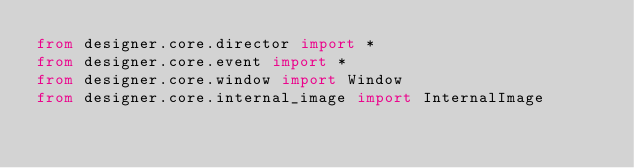Convert code to text. <code><loc_0><loc_0><loc_500><loc_500><_Python_>from designer.core.director import *
from designer.core.event import *
from designer.core.window import Window
from designer.core.internal_image import InternalImage
</code> 